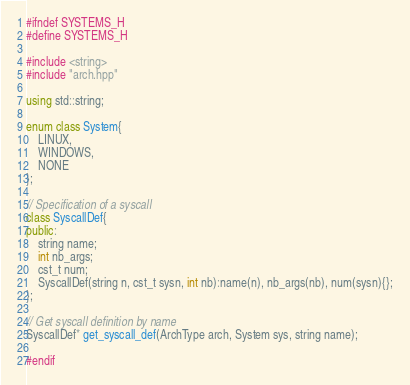Convert code to text. <code><loc_0><loc_0><loc_500><loc_500><_C++_>#ifndef SYSTEMS_H
#define SYSTEMS_H

#include <string>
#include "arch.hpp"

using std::string;

enum class System{
    LINUX,
    WINDOWS,
    NONE
};

// Specification of a syscall
class SyscallDef{
public:
    string name;
    int nb_args;
    cst_t num;
    SyscallDef(string n, cst_t sysn, int nb):name(n), nb_args(nb), num(sysn){};
};

// Get syscall definition by name
SyscallDef* get_syscall_def(ArchType arch, System sys, string name);

#endif
</code> 